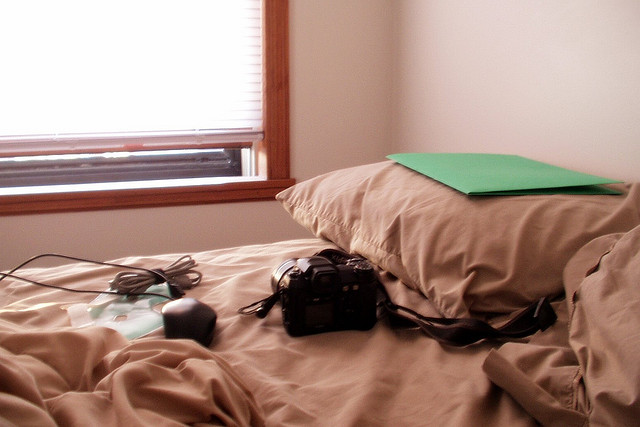<image>Where are the shoes? The location of the shoes is unknown. They might be on the floor, on the bed, or in the closet. Where are the shoes? I don't know where the shoes are. It is not clear from the given information. 